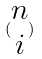<formula> <loc_0><loc_0><loc_500><loc_500>( \begin{matrix} n \\ i \end{matrix} )</formula> 